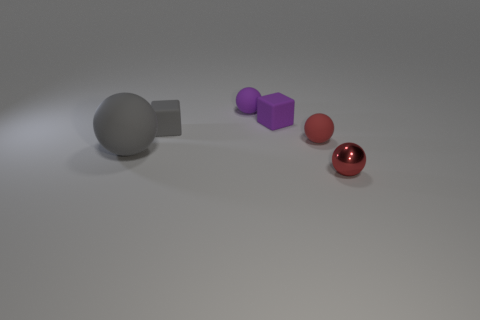Do the red thing behind the gray ball and the gray sphere have the same material?
Provide a short and direct response. Yes. Is there another gray matte object of the same shape as the tiny gray rubber object?
Make the answer very short. No. Are there an equal number of tiny rubber balls on the right side of the purple ball and cubes?
Keep it short and to the point. No. What material is the small thing in front of the small red sphere behind the red metallic thing made of?
Your answer should be very brief. Metal. What is the shape of the big gray matte thing?
Keep it short and to the point. Sphere. Are there the same number of small cubes in front of the red metal ball and small red metal objects right of the gray sphere?
Your answer should be compact. No. There is a ball in front of the large rubber sphere; does it have the same color as the tiny matte thing that is in front of the small gray cube?
Your answer should be compact. Yes. Is the number of tiny rubber cubes that are to the right of the tiny gray object greater than the number of tiny cyan shiny blocks?
Provide a succinct answer. Yes. There is a big object that is the same material as the small gray thing; what shape is it?
Your response must be concise. Sphere. Is the size of the red ball behind the red metallic sphere the same as the big gray rubber ball?
Keep it short and to the point. No. 